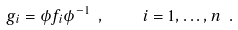<formula> <loc_0><loc_0><loc_500><loc_500>g _ { i } = \phi f _ { i } \phi ^ { - 1 } \ , \quad i = 1 , \dots , n \ .</formula> 